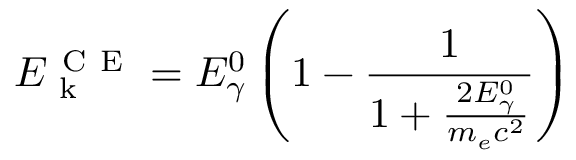Convert formula to latex. <formula><loc_0><loc_0><loc_500><loc_500>E _ { k } ^ { C E } = E _ { \gamma } ^ { 0 } \left ( 1 - \frac { 1 } { 1 + \frac { 2 E _ { \gamma } ^ { 0 } } { m _ { e } c ^ { 2 } } } \right )</formula> 